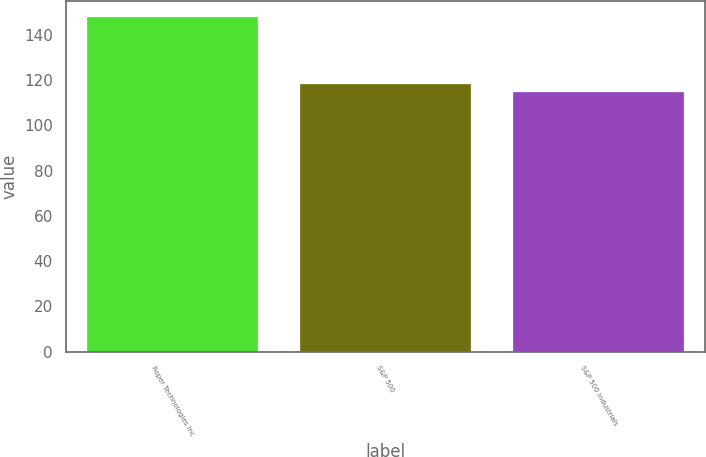Convert chart to OTSL. <chart><loc_0><loc_0><loc_500><loc_500><bar_chart><fcel>Roper Technologies Inc<fcel>S&P 500<fcel>S&P 500 Industrials<nl><fcel>147.73<fcel>118.45<fcel>114.67<nl></chart> 